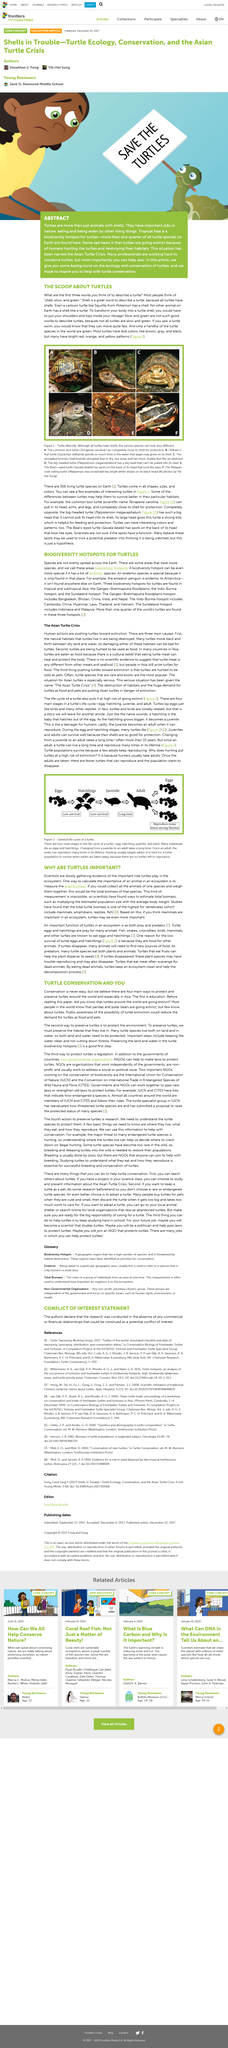Give some essential details in this illustration. The Turtle species is facing extinction due to the reasons of human hunting and habitat destruction. It is a myth that most turtles in the world are green. In reality, they have dull colors that are predominant. A biodiversity hotspot is a region that boasts a higher concentration of species relative to the surrounding area, making it a vital conservation priority. Protecting the environment is the second way to increase the population's lifespan, as it is essential for the survival and well-being of future generations. The Indo-Burma hotspot is one of the three biodiversity hotspots for turtles, known for its rich and diverse turtle populations. 